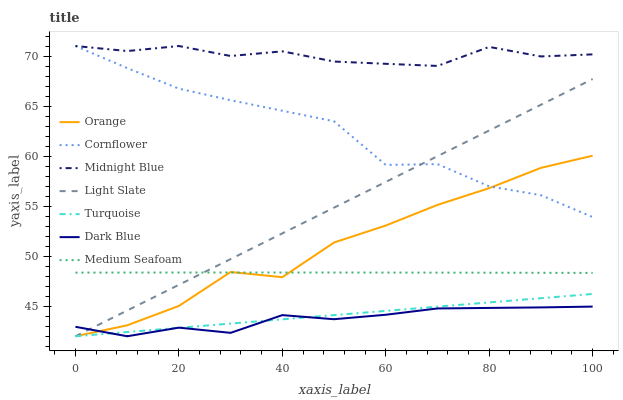Does Turquoise have the minimum area under the curve?
Answer yes or no. No. Does Turquoise have the maximum area under the curve?
Answer yes or no. No. Is Midnight Blue the smoothest?
Answer yes or no. No. Is Midnight Blue the roughest?
Answer yes or no. No. Does Midnight Blue have the lowest value?
Answer yes or no. No. Does Turquoise have the highest value?
Answer yes or no. No. Is Turquoise less than Cornflower?
Answer yes or no. Yes. Is Medium Seafoam greater than Dark Blue?
Answer yes or no. Yes. Does Turquoise intersect Cornflower?
Answer yes or no. No. 